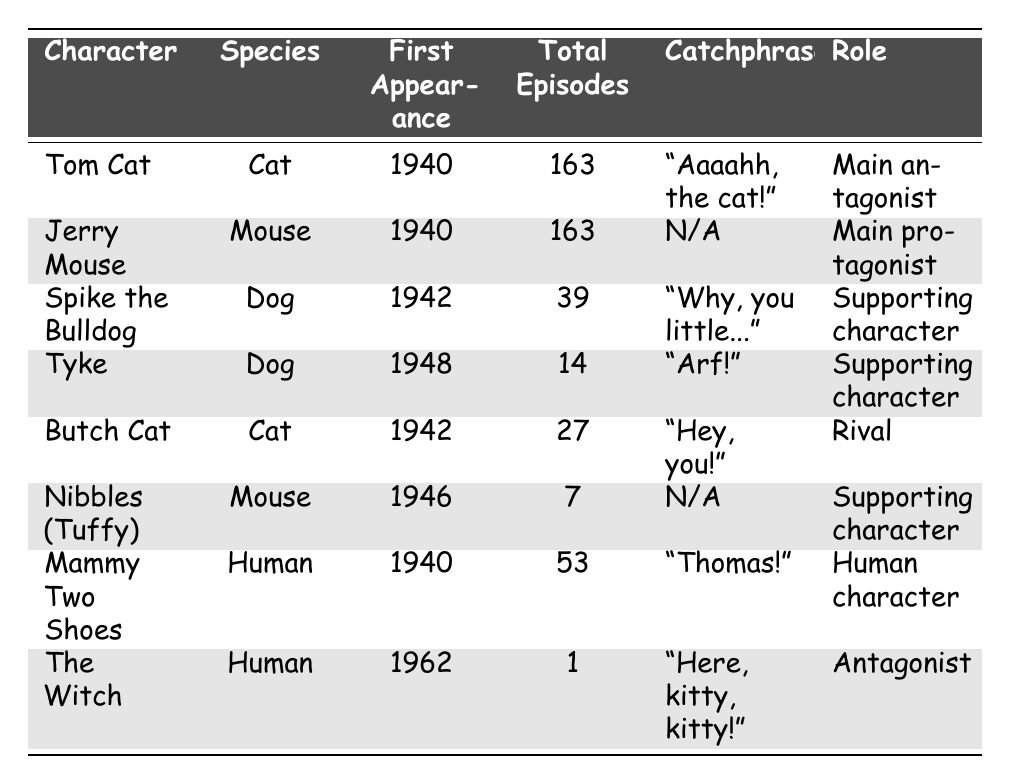What is the first appearance year of Tom Cat? Tom Cat's first appearance year can be found directly in the table under the "First Appearance" column. It states 1940.
Answer: 1940 How many total episodes did Jerry Mouse appear in? Jerry Mouse is listed in the table with a total of 163 episodes in the "Total Episodes" column.
Answer: 163 Which character has the least number of total episodes? By examining the "Total Episodes" column, we see that Nibbles (Tuffy) has the least with 7 episodes.
Answer: Nibbles (Tuffy) Is Mammy Two Shoes a cat character? Mammy Two Shoes is classified as a "Human" character in the "Species" column, so she is not a cat.
Answer: No Who is the main protagonist? The main protagonist is listed as Jerry Mouse in the "Role" column, clearly stated as "Main protagonist."
Answer: Jerry Mouse What is the catchphrase of the character Butch Cat? Looking at the table, Butch Cat's catchphrase is found under the "Catchphrase" column, which states "Hey, you!"
Answer: Hey, you! Which characters were introduced in 1942? By reviewing the "First Appearance" column, both Spike the Bulldog and Butch Cat are identified as introduced in 1942.
Answer: Spike the Bulldog, Butch Cat How many more episodes did Tom Cat appear in compared to Tyke? Tom Cat has 163 episodes and Tyke has 14 episodes. So, 163 - 14 = 149 episodes more.
Answer: 149 Which species has the most representations in the table? The table contains three "Cat" characters (Tom Cat, Butch Cat) and two "Mouse" characters (Jerry Mouse, Nibbles). Therefore, the species with the most representations is "Cat."
Answer: Cat Is the first appearance of any human character earlier than any animal character? The first appearance of Mammy Two Shoes (1940) is the same year as Tom Cat and Jerry Mouse but later than Spike and Butch, both appearing in 1942. Therefore, none of the human characters appeared earlier than the animal characters.
Answer: No What percentage of total episodes does Spike the Bulldog have compared to Tom Cat? Spike the Bulldog has 39 episodes and Tom Cat has 163 episodes. To find the percentage: (39/163) * 100 ≈ 23.93%.
Answer: 23.93% 